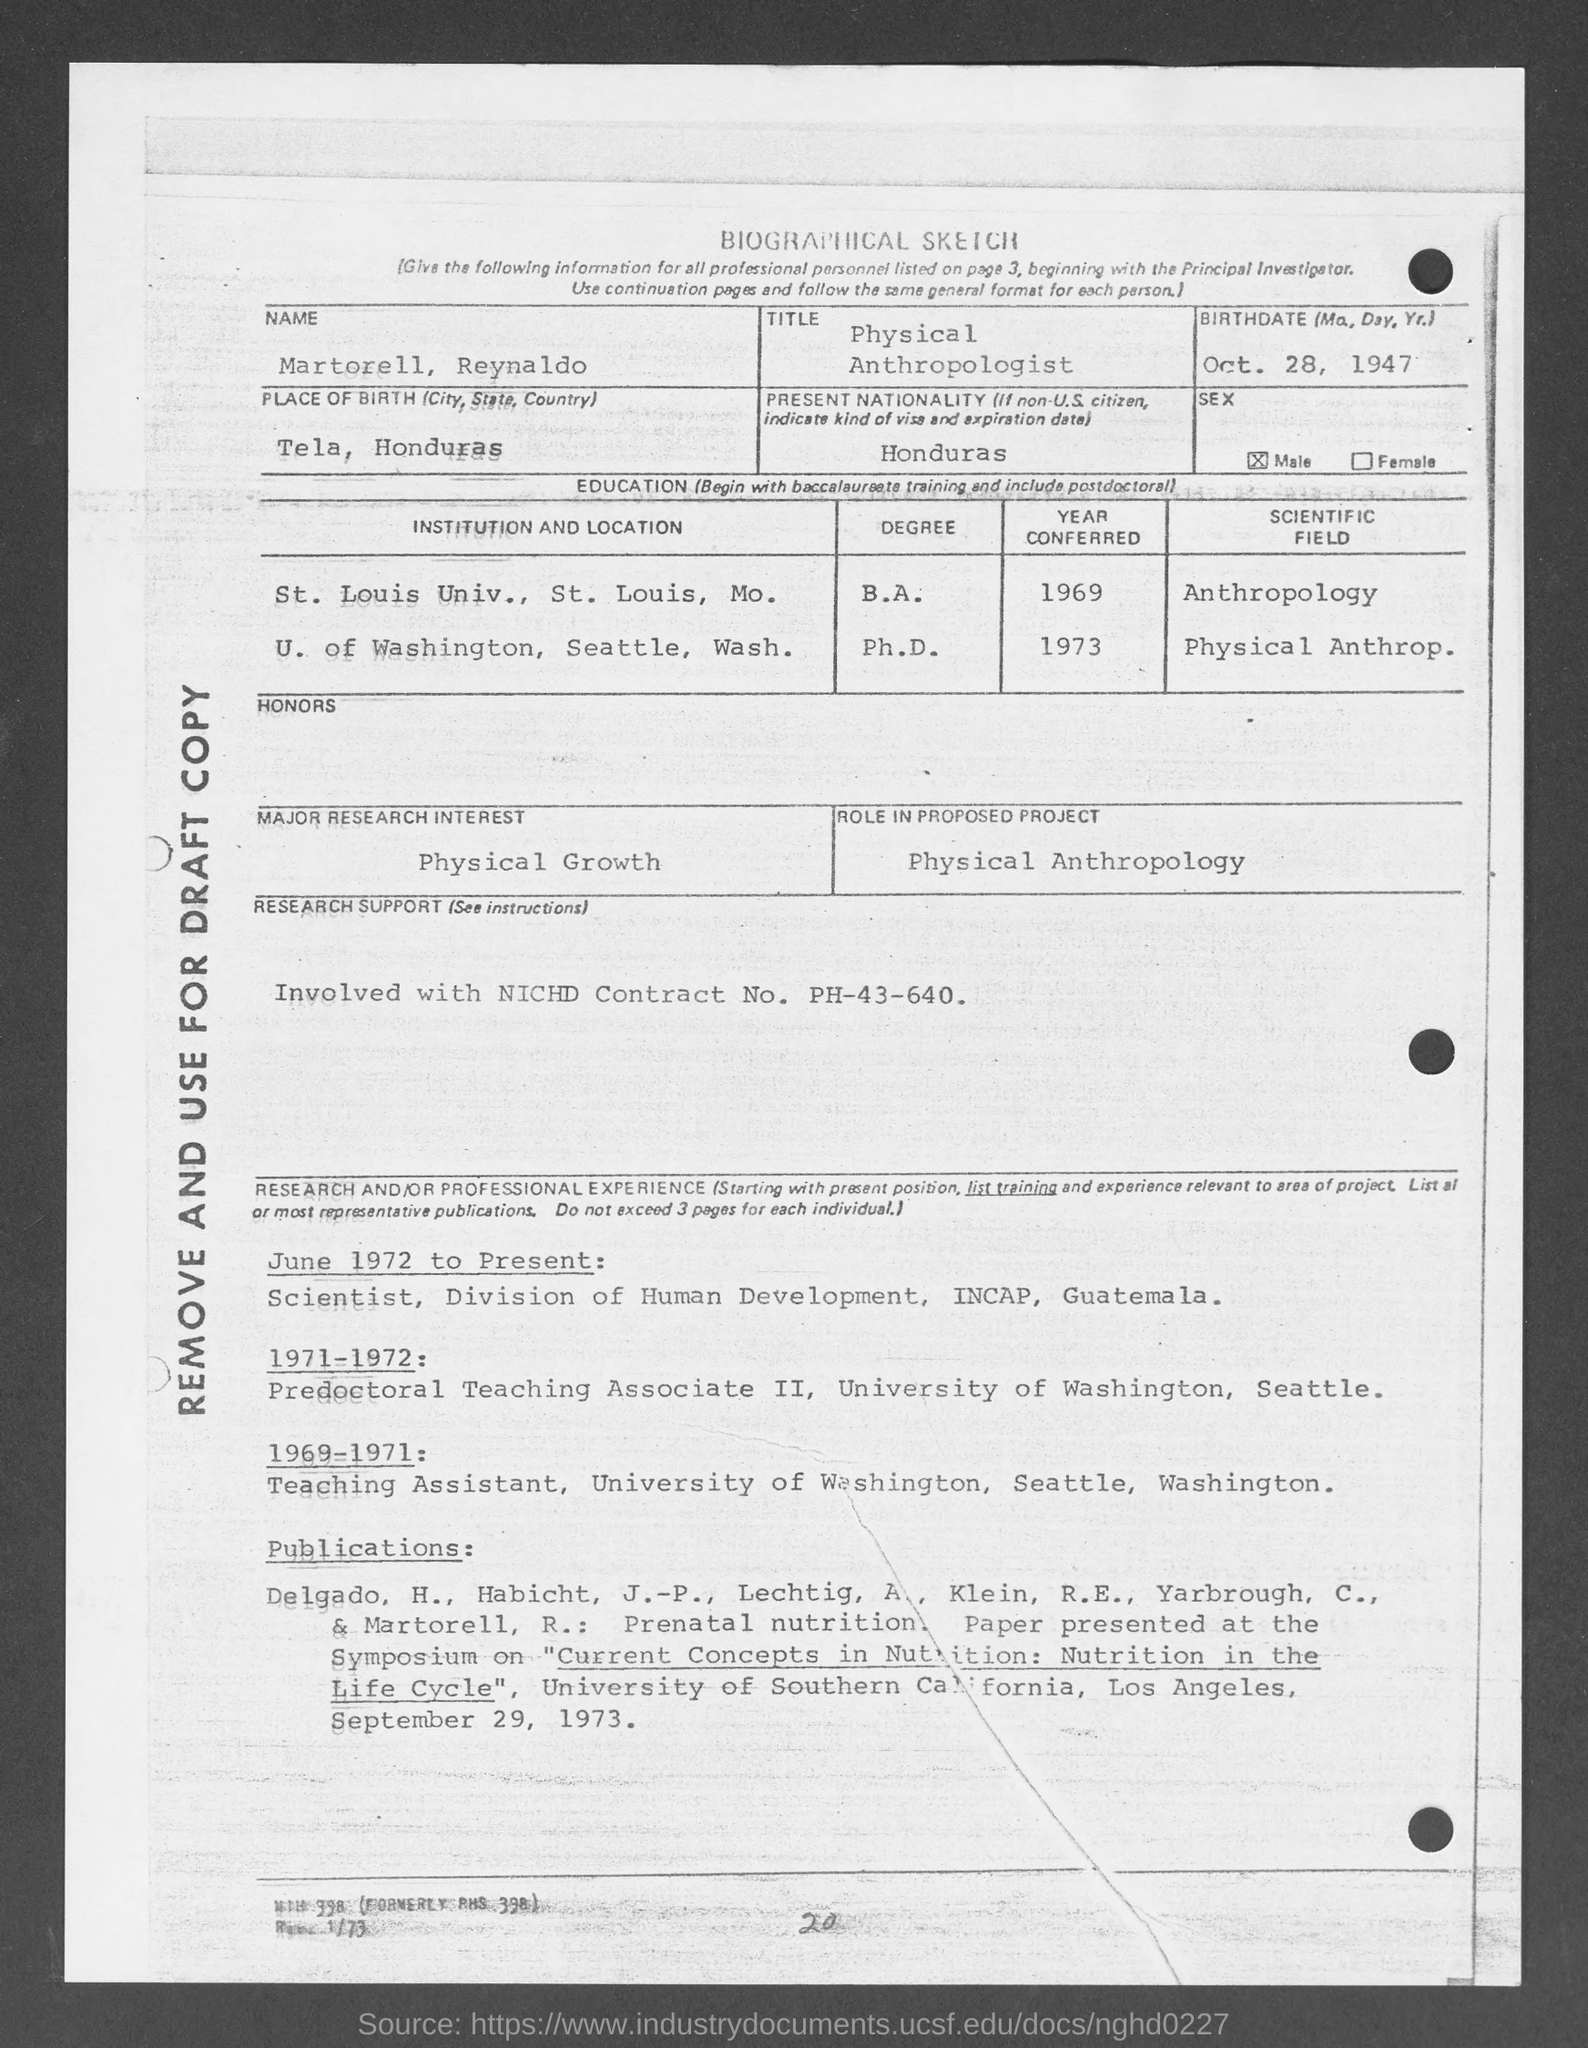What is the name mentioned in the given biographical sketch ?
Your answer should be very brief. Martorell Reynaldo. What is the birthdate mentioned in the given sketch ?
Your answer should be compact. Oct. 28, 1947. Where is the place of birth as mentioned in the given sketch ?
Your response must be concise. Tela, honduras. What is the present nationality as mentioned in the given sketch ?
Make the answer very short. Honduras. What is the sex mentioned in the given sketch ?
Provide a short and direct response. Male. What is the major research interest mentioned in the given sketch ?
Provide a succinct answer. Physical growth. What is the role in proposed project as mentioned in the given sketch ?
Keep it short and to the point. Physical anthropology. In which year martorell, reynaldo conferred his ph.d. in physical anthropology ?
Give a very brief answer. 1973. 